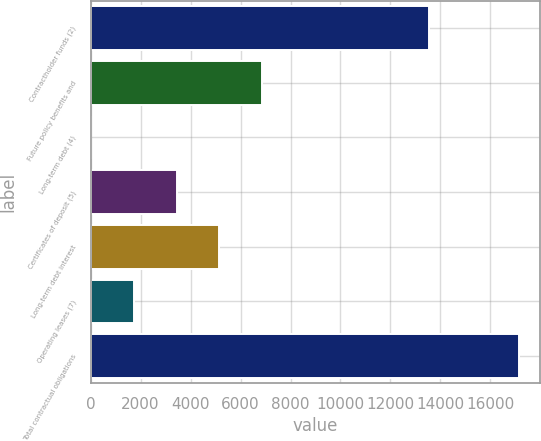Convert chart to OTSL. <chart><loc_0><loc_0><loc_500><loc_500><bar_chart><fcel>Contractholder funds (2)<fcel>Future policy benefits and<fcel>Long-term debt (4)<fcel>Certificates of deposit (5)<fcel>Long-term debt interest<fcel>Operating leases (7)<fcel>Total contractual obligations<nl><fcel>13560.3<fcel>6860.78<fcel>17.5<fcel>3439.14<fcel>5149.96<fcel>1728.32<fcel>17125.7<nl></chart> 